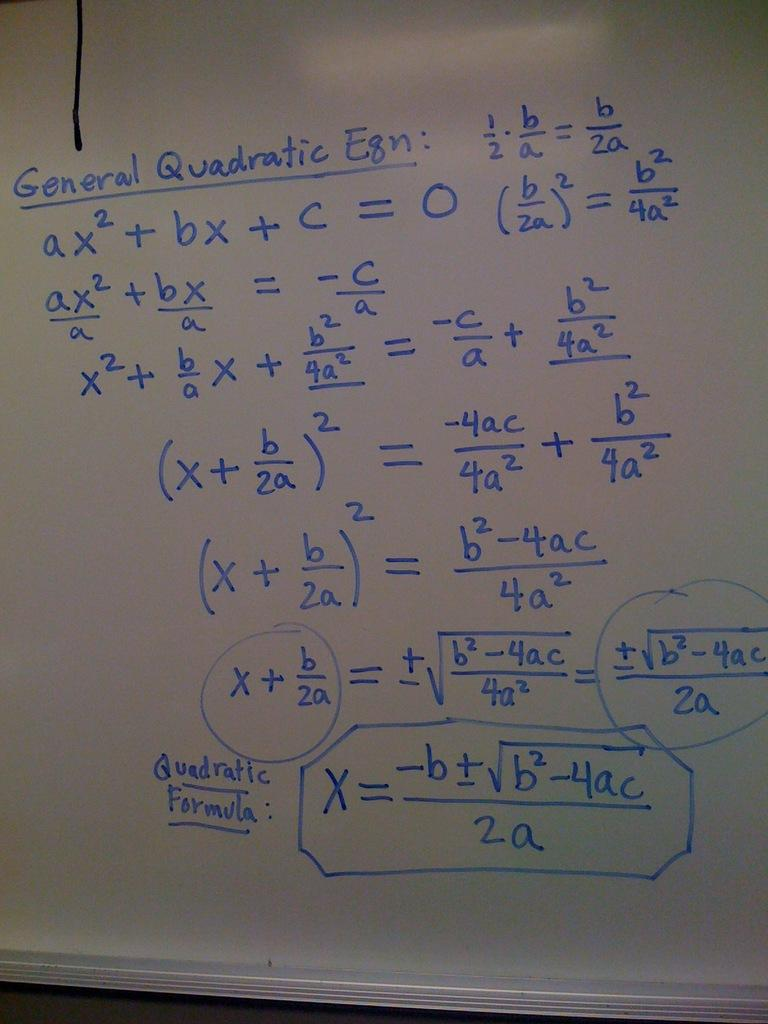<image>
Summarize the visual content of the image. A complex math problem is written in blue on a dry-erase board and shows the quadratic formula at the bottom. 